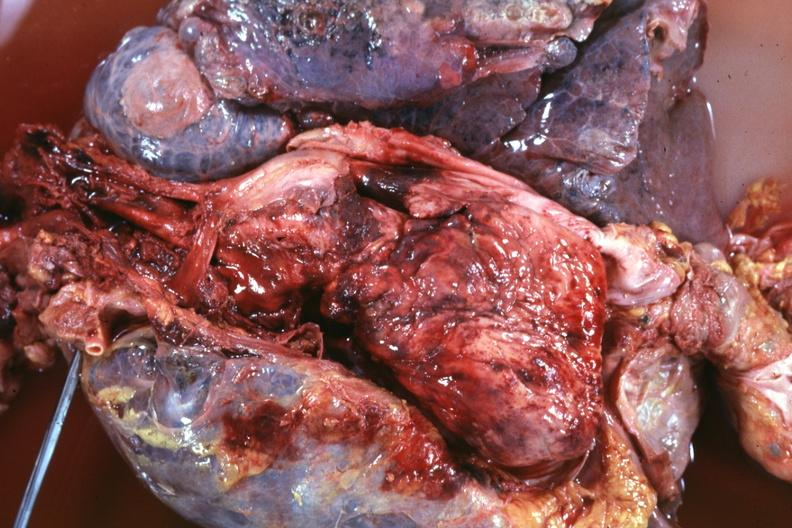s thymus present?
Answer the question using a single word or phrase. Yes 